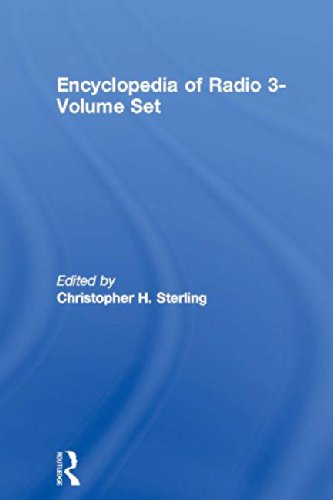What is the title of this book? The title of the book depicted in the image is 'Encyclopedia of Radio 3-Volume Set'. This comprehensive encyclopedia offers in-depth information on the history and technology of radio. 